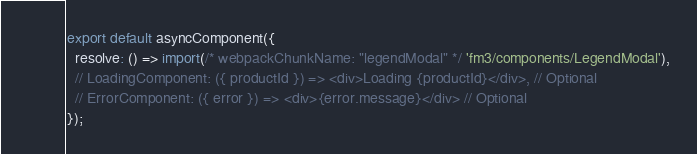Convert code to text. <code><loc_0><loc_0><loc_500><loc_500><_JavaScript_>export default asyncComponent({
  resolve: () => import(/* webpackChunkName: "legendModal" */ 'fm3/components/LegendModal'),
  // LoadingComponent: ({ productId }) => <div>Loading {productId}</div>, // Optional
  // ErrorComponent: ({ error }) => <div>{error.message}</div> // Optional
});
</code> 